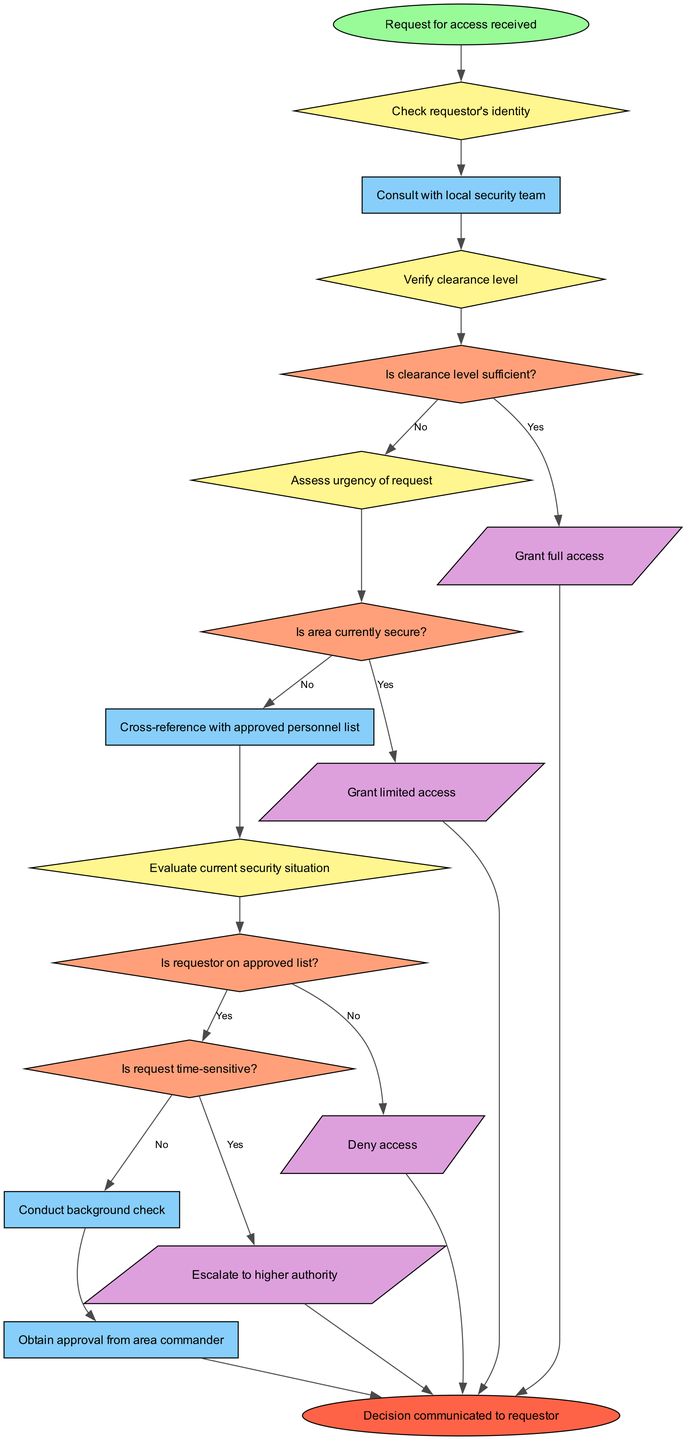What is the starting point of the diagram? The starting point is indicated by the "start" node labeled "Request for access received", which marks the beginning of the decision-making process in the diagram.
Answer: Request for access received How many decision nodes are present in the flowchart? Counting the nodes specifically labeled as decision nodes, there are four decision nodes listed in the diagram which are essential for evaluating the access request.
Answer: 4 What is the final output node of the diagram? The final output node is the last decision result communicated in the flowchart, which is labeled "Decision communicated to requestor" indicating the end of the decision process.
Answer: Decision communicated to requestor If the requestor is not on the approved list, what is the next step? From the decision node regarding whether the requestor is on the approved list, if the answer is "No", it directly leads to the output node labeled "Deny access", showing that access will not be granted.
Answer: Deny access Which process node follows consulting with the local security team? The process node that directly follows consulting with the local security team is conducting a background check, indicating the subsequent step that must be taken after the initial consultation.
Answer: Conduct background check What decision is made if the clearance level is sufficient? If the clearance level is determined to be sufficient, the flowchart indicates a direct path to granting full access, showing a favorable outcome for the access request.
Answer: Grant full access Which node evaluates the current security situation? The node that focuses specifically on evaluating the current security situation is labeled "Evaluate current security situation," and is critical in assessing the conditions surrounding the access request.
Answer: Evaluate current security situation What does the diamond-shaped node represent in the context of the flowchart? In the context of the flowchart, the diamond-shaped nodes represent decision points where a yes/no evaluation is made, directing the flow of the process based on the answers provided.
Answer: Decision points What happens if the request is determined to be time-sensitive? If the request is assessed to be time-sensitive, the flowchart indicates that it leads directly to the output node labeled "Grant limited access," reflecting a quicker response based on urgency.
Answer: Grant limited access 